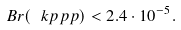Convert formula to latex. <formula><loc_0><loc_0><loc_500><loc_500>B r ( \ k p p p ) < 2 . 4 \cdot 1 0 ^ { - 5 } .</formula> 